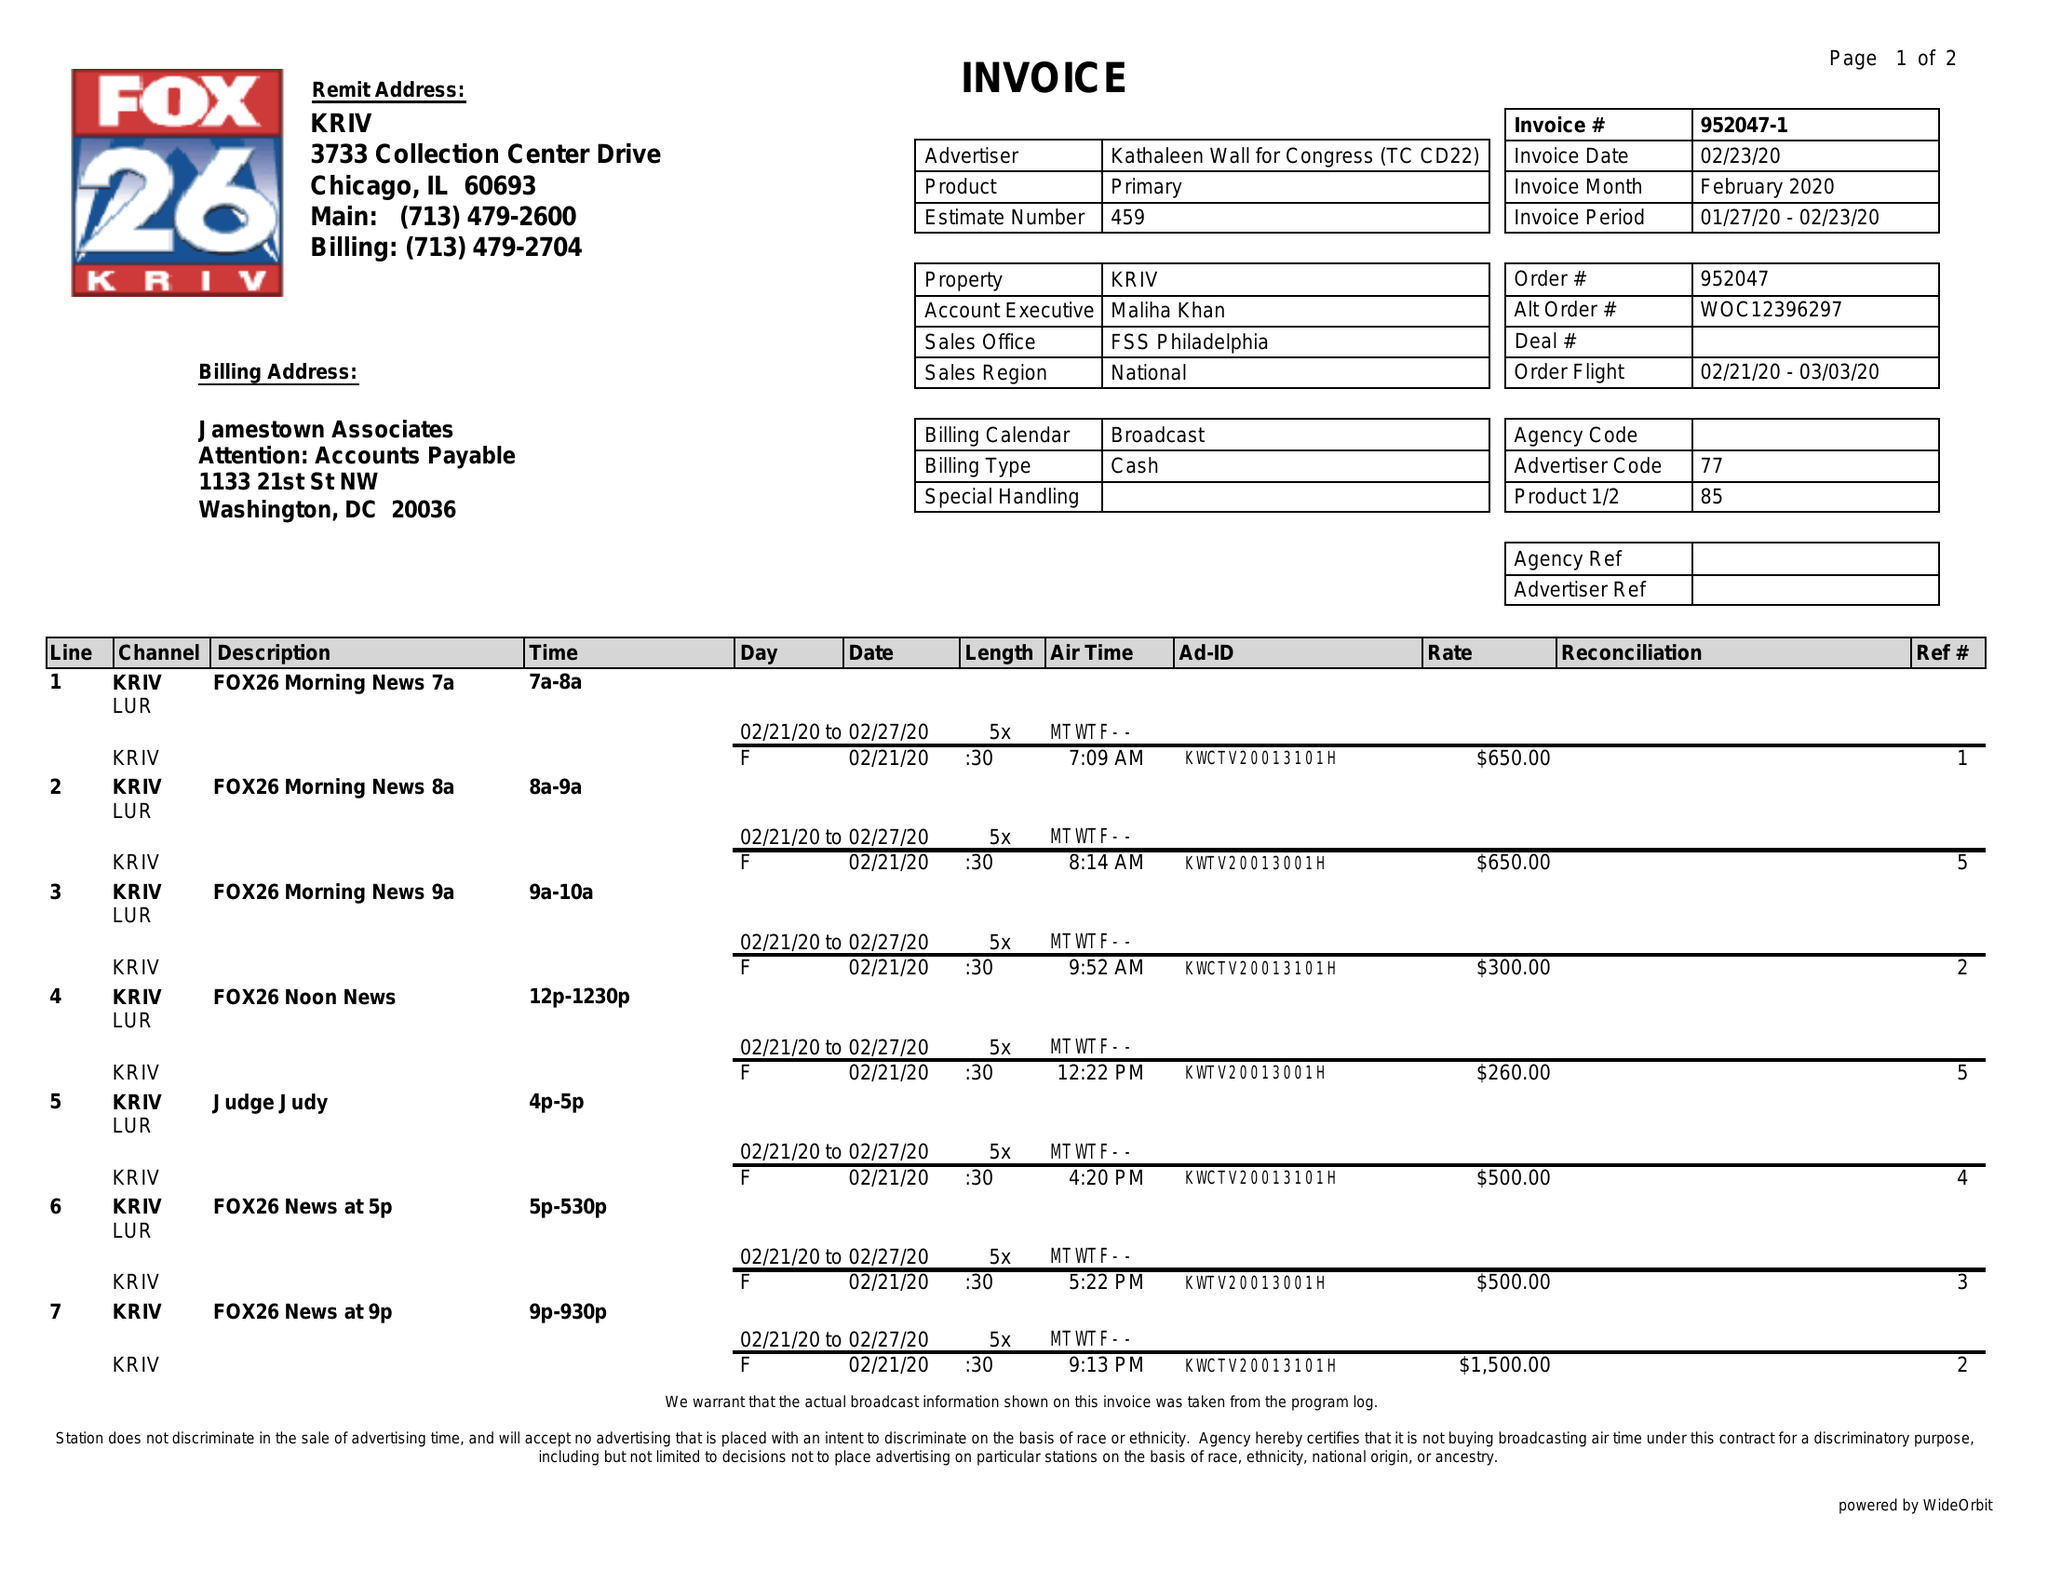What is the value for the advertiser?
Answer the question using a single word or phrase. KATHALEEN WALL FOR CONGRESS (TC CD22) 